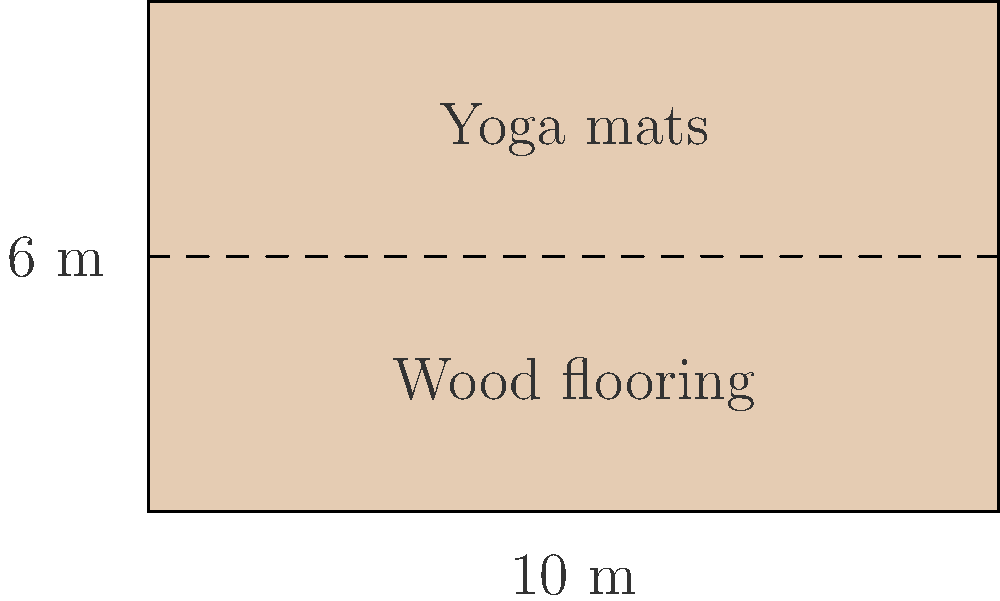A new yoga studio is being constructed in a renovated warehouse in Brooklyn. The studio floor measures 10 m by 6 m and consists of engineered hardwood flooring. If the floor needs to support a maximum of 30 people (average weight 70 kg) plus equipment (total weight 500 kg), and the building code requires a safety factor of 1.5, what is the minimum required load-bearing capacity of the floor in kN/m²? To calculate the minimum required load-bearing capacity, we'll follow these steps:

1. Calculate the total weight to be supported:
   - People: $30 \times 70 \text{ kg} = 2100 \text{ kg}$
   - Equipment: $500 \text{ kg}$
   - Total weight: $2100 + 500 = 2600 \text{ kg}$

2. Convert weight to force:
   $F = mg$, where $g = 9.81 \text{ m/s²}$
   $F = 2600 \text{ kg} \times 9.81 \text{ m/s²} = 25,506 \text{ N} = 25.506 \text{ kN}$

3. Apply the safety factor:
   $25.506 \text{ kN} \times 1.5 = 38.259 \text{ kN}$

4. Calculate the floor area:
   $A = 10 \text{ m} \times 6 \text{ m} = 60 \text{ m²}$

5. Calculate the load-bearing capacity per square meter:
   $\frac{38.259 \text{ kN}}{60 \text{ m²}} = 0.638 \text{ kN/m²}$

Therefore, the minimum required load-bearing capacity is 0.638 kN/m².
Answer: 0.638 kN/m² 